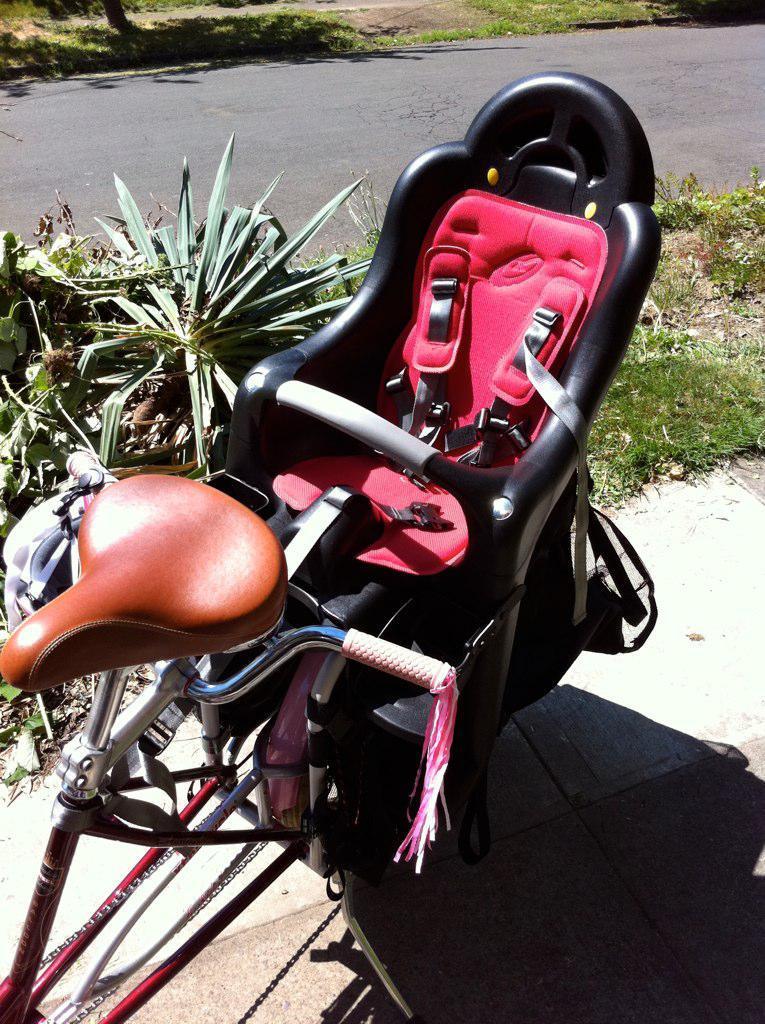Please provide a concise description of this image. In this picture there is a black and pink color seat placed on the bicycle. Behind there are some small plants and road. 